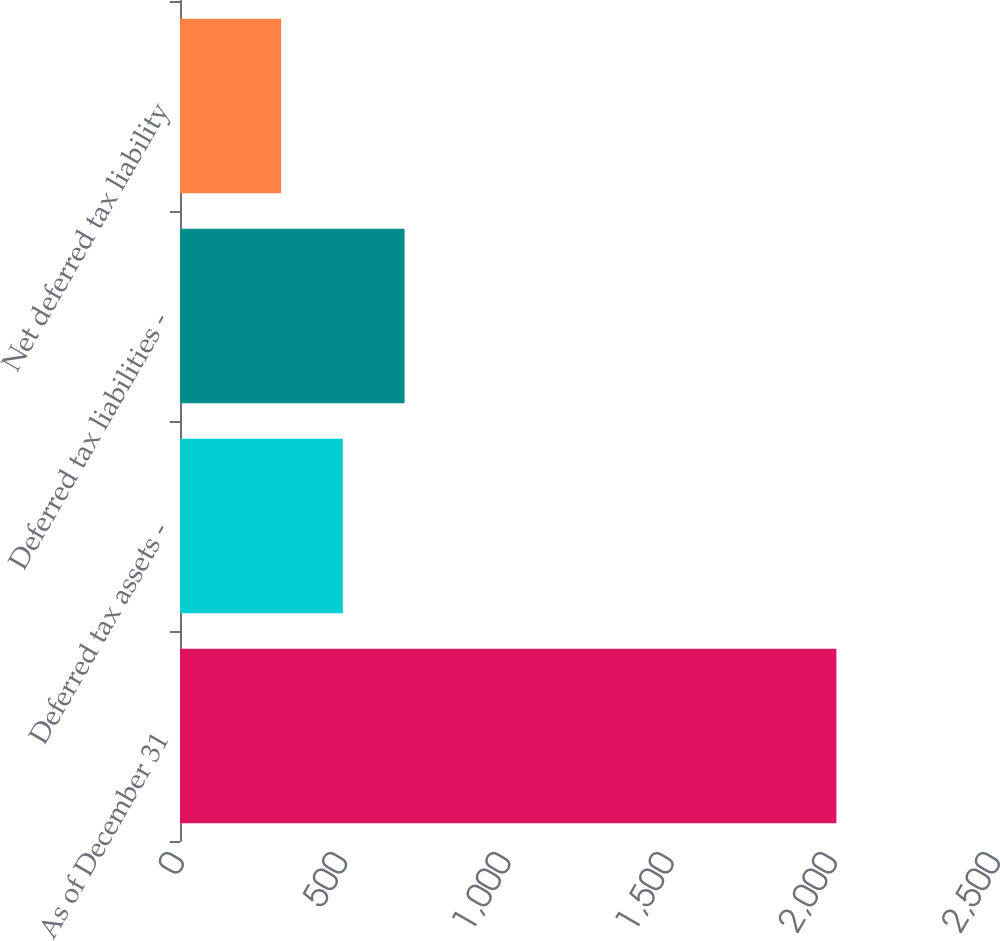<chart> <loc_0><loc_0><loc_500><loc_500><bar_chart><fcel>As of December 31<fcel>Deferred tax assets -<fcel>Deferred tax liabilities -<fcel>Net deferred tax liability<nl><fcel>2011<fcel>499<fcel>688<fcel>310<nl></chart> 